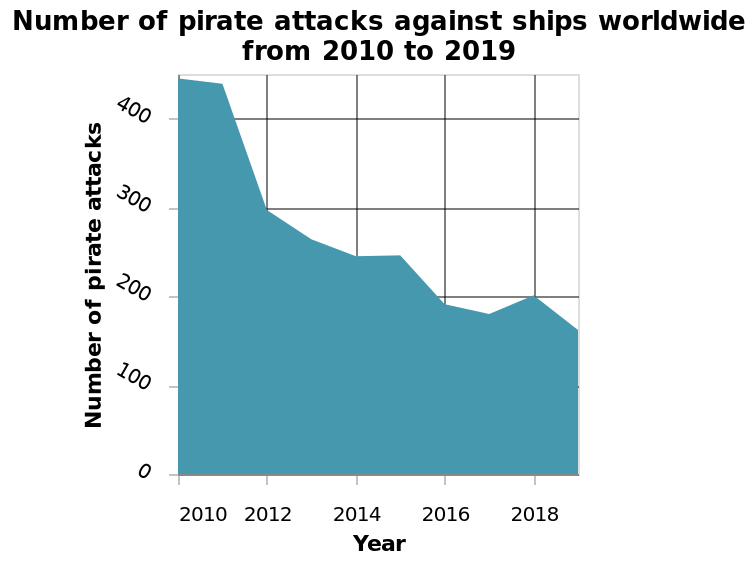<image>
What type of chart is used to represent the number of pirate attacks against ships worldwide from 2010 to 2019? An area chart is used to represent the number of pirate attacks against ships worldwide from 2010 to 2019. Offer a thorough analysis of the image. The years go up by the increments of 2. The number of pirate attacks go up by the increments of 100. The area graph is blue in colour with a white background. The overall number of pirate attacks has decreased from over 400 in 2010 to around 175 in 2019. How many pirate attacks were recorded in 2010 and 2019? In 2010, there were over 400 pirate attacks, while in 2019, the number decreased to around 175 pirate attacks. In what time period does the area chart represent the number of pirate attacks against ships worldwide? The area chart represents the number of pirate attacks against ships worldwide from 2010 to 2019. What are the minimum and maximum values on the y-axis? The minimum value on the y-axis is 0 and the maximum value is 400. How much did the number of pirate attacks decrease from 2010 to 2019? The number of pirate attacks decreased by approximately 225 from 2010 to 2019. 